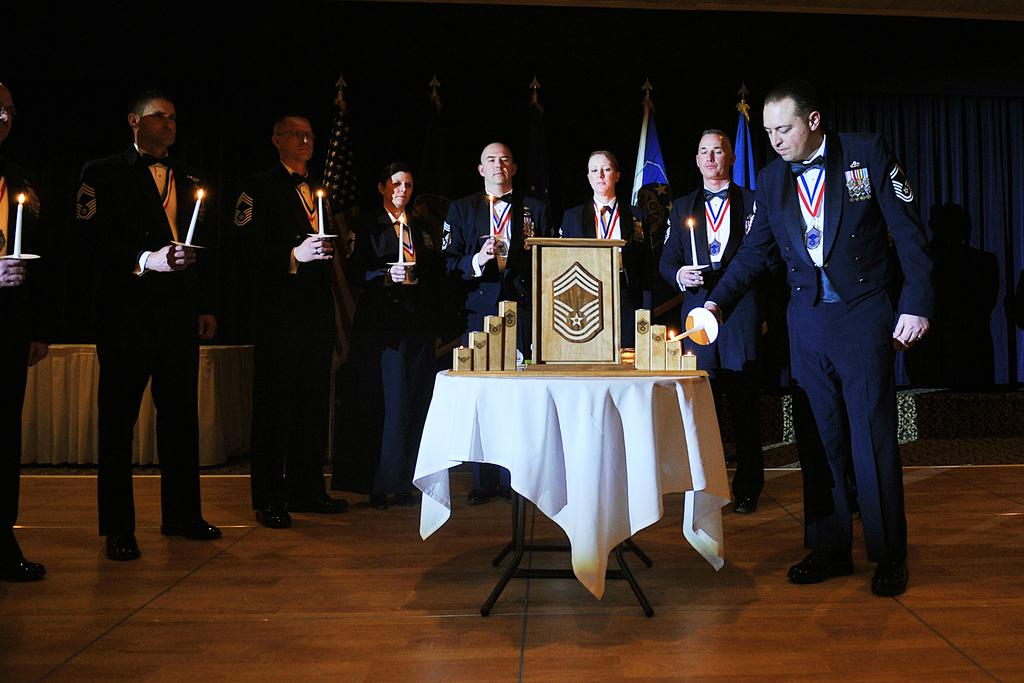What are the people in the image doing? The people in the image are standing and holding candles. What object can be seen in the image besides the people? There is a table in the image. What is covering the table? There is a tablecloth on the table. What can be seen in the background of the image? There are flags in the background of the image. Where is the sofa located in the image? There is no sofa present in the image. What type of hen can be seen in the image? There is no hen present in the image. 